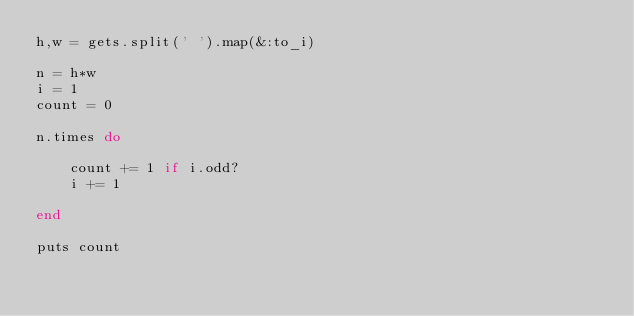<code> <loc_0><loc_0><loc_500><loc_500><_Ruby_>h,w = gets.split(' ').map(&:to_i)

n = h*w
i = 1
count = 0

n.times do

	count += 1 if i.odd?
	i += 1
	
end

puts count</code> 